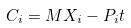<formula> <loc_0><loc_0><loc_500><loc_500>C _ { i } = M X _ { i } - P _ { i } t</formula> 